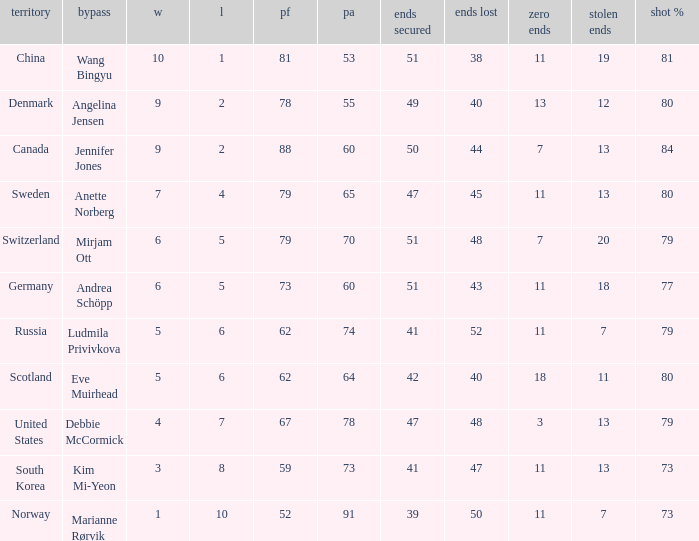What is the minimum Wins a team has? 1.0. Parse the full table. {'header': ['territory', 'bypass', 'w', 'l', 'pf', 'pa', 'ends secured', 'ends lost', 'zero ends', 'stolen ends', 'shot %'], 'rows': [['China', 'Wang Bingyu', '10', '1', '81', '53', '51', '38', '11', '19', '81'], ['Denmark', 'Angelina Jensen', '9', '2', '78', '55', '49', '40', '13', '12', '80'], ['Canada', 'Jennifer Jones', '9', '2', '88', '60', '50', '44', '7', '13', '84'], ['Sweden', 'Anette Norberg', '7', '4', '79', '65', '47', '45', '11', '13', '80'], ['Switzerland', 'Mirjam Ott', '6', '5', '79', '70', '51', '48', '7', '20', '79'], ['Germany', 'Andrea Schöpp', '6', '5', '73', '60', '51', '43', '11', '18', '77'], ['Russia', 'Ludmila Privivkova', '5', '6', '62', '74', '41', '52', '11', '7', '79'], ['Scotland', 'Eve Muirhead', '5', '6', '62', '64', '42', '40', '18', '11', '80'], ['United States', 'Debbie McCormick', '4', '7', '67', '78', '47', '48', '3', '13', '79'], ['South Korea', 'Kim Mi-Yeon', '3', '8', '59', '73', '41', '47', '11', '13', '73'], ['Norway', 'Marianne Rørvik', '1', '10', '52', '91', '39', '50', '11', '7', '73']]} 